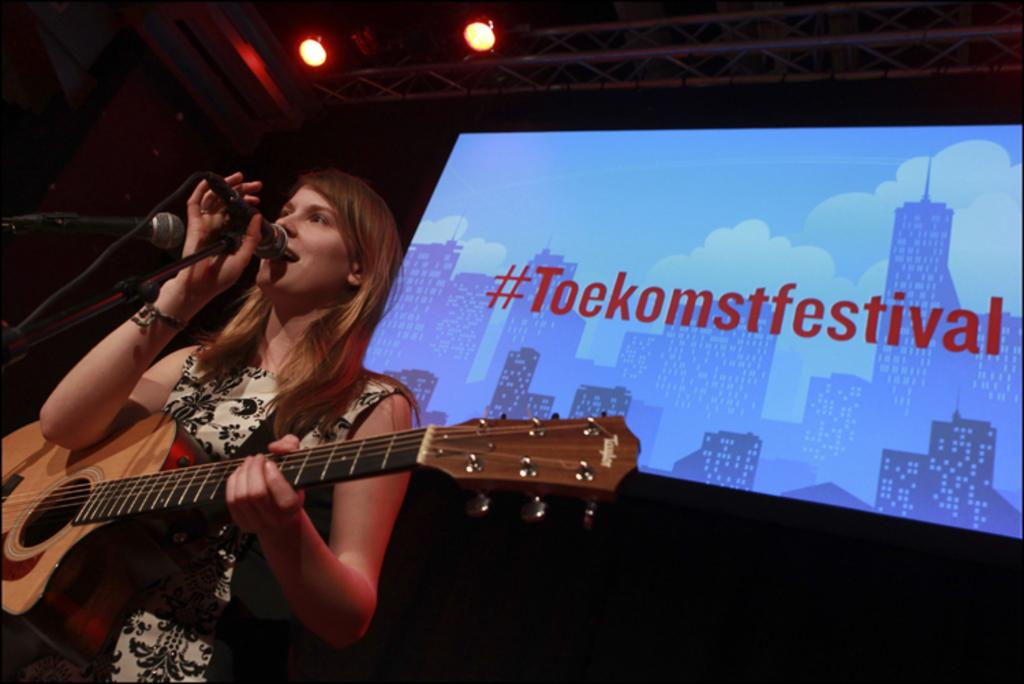What is in the background of the image? There is a screen in the background of the image. What can be seen in addition to the screen? There are lights visible in the image. What is the woman in front of in the image? The woman is in front of a microphone. What is the woman holding in her hands? The woman is holding a guitar in her hands. What is the woman doing in the image? The woman is singing. What type of zipper can be seen on the woman's clothing in the image? There is no zipper visible on the woman's clothing in the image. What animal is present in the image? There are no animals present in the image; it features a woman singing with a guitar. 